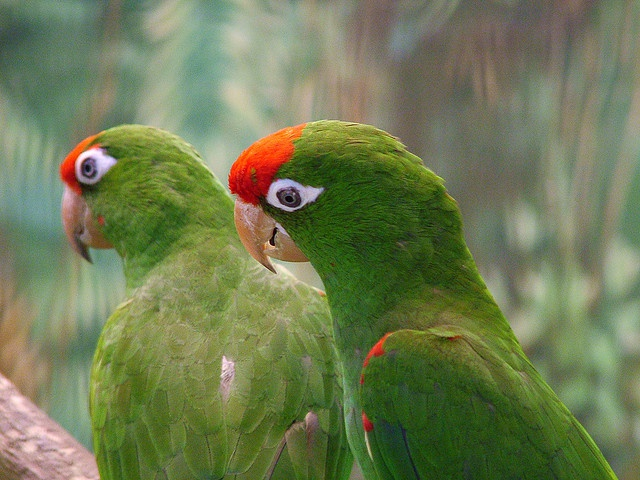Describe the objects in this image and their specific colors. I can see bird in green, darkgreen, and olive tones and bird in green, darkgreen, and olive tones in this image. 